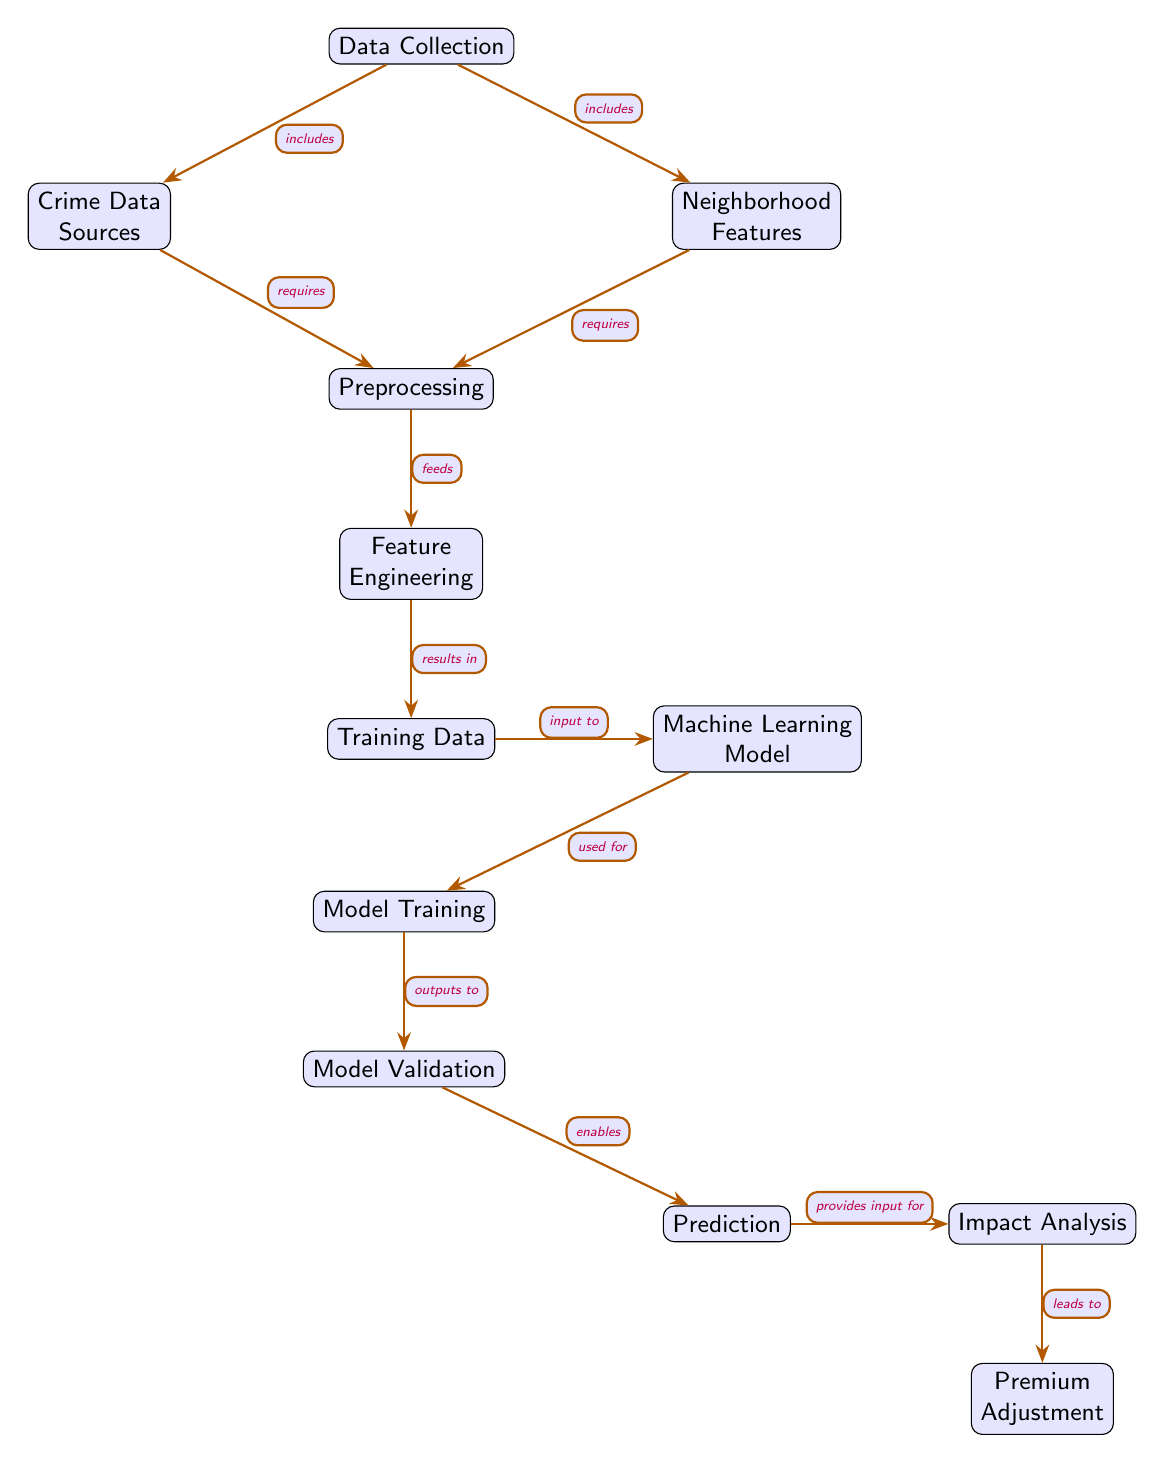What's the starting point of this diagram? The diagram begins with the node labeled "Data Collection," which is the first step in the flowchart. This node indicates the initial activity required for the property crime risk assessment.
Answer: Data Collection How many nodes are in the diagram? To determine the number of nodes, we count each distinct element in the diagram, which includes all steps from data collection to premium adjustment. Counting these gives us a total of twelve nodes.
Answer: 12 What follows "Model Validation"? Immediately after "Model Validation," the next step in the diagram is "Prediction," which represents the output stage of the modeling process after validation is completed.
Answer: Prediction Which nodes are included in the impact analysis process? The impact analysis process starts from the node "Prediction," leading to "Impact Analysis," and finally to "Premium Adjustment." These steps represent analyzing the predicted model results to adjust insurance premiums accordingly.
Answer: Impact Analysis, Premium Adjustment What type of data is required for preprocessing? Both "Crime Data Sources" and "Neighborhood Features" feed into "Preprocessing", meaning that these types of data are essential for preparing the information for further analysis.
Answer: Crime Data Sources, Neighborhood Features What does "Feature Engineering" produce? "Feature Engineering" produces "Training Data," which involves the transformation and selection of relevant features for training the machine learning model. This is a crucial step before the model is trained.
Answer: Training Data What is the relationship between "Machine Learning Model" and "Model Training"? The "Machine Learning Model" is a result of the "Training Data," and it undergoes "Model Training" to learn from the data. "Model Training" is thus a process that uses the model built with the training data.
Answer: Used for What leads to "Premium Adjustment"? The process flows from "Impact Analysis" to "Premium Adjustment," meaning that the results and insights gained from the impact analysis directly inform the changes made to insurance premiums.
Answer: Impact Analysis What is the main purpose of "Prediction" in this diagram? The main purpose of "Prediction" is to provide insights based on the validated model to assess risk levels in neighborhoods, which ultimately influences the insurance premium calculations.
Answer: Assess risk levels 